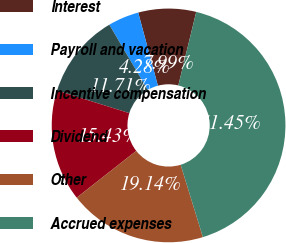<chart> <loc_0><loc_0><loc_500><loc_500><pie_chart><fcel>Interest<fcel>Payroll and vacation<fcel>Incentive compensation<fcel>Dividend<fcel>Other<fcel>Accrued expenses<nl><fcel>7.99%<fcel>4.28%<fcel>11.71%<fcel>15.43%<fcel>19.14%<fcel>41.45%<nl></chart> 